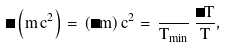<formula> <loc_0><loc_0><loc_500><loc_500>\Delta \left ( m \, c ^ { 2 } \right ) = \, ( \Delta m ) \, c ^ { 2 } = \, \frac { } { T _ { \min } } \, \frac { \Delta { T } } { T } ,</formula> 